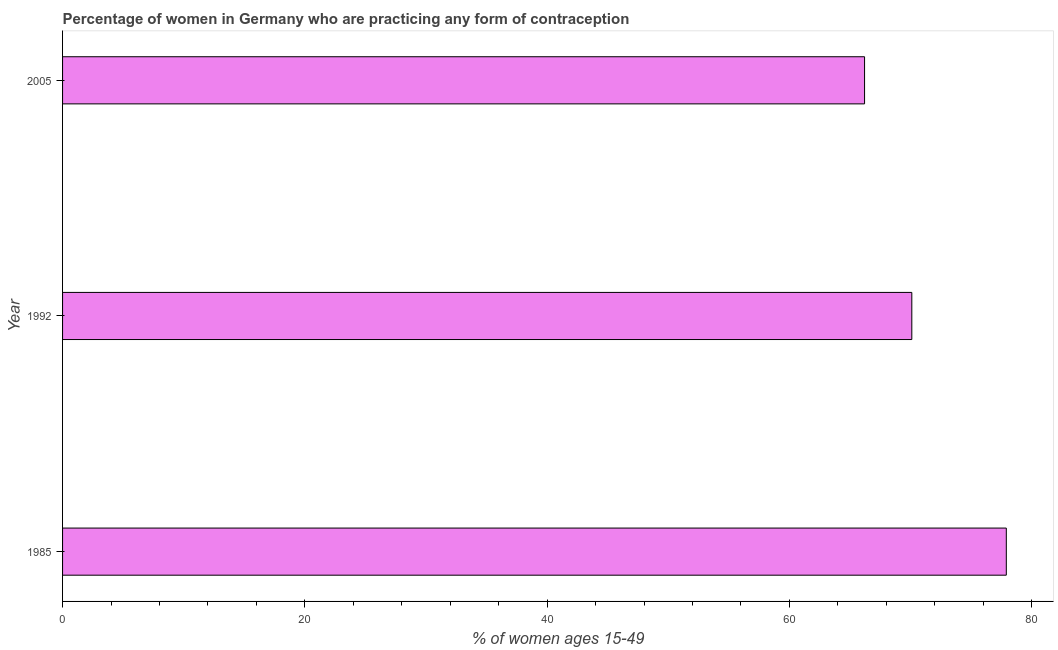Does the graph contain any zero values?
Your response must be concise. No. Does the graph contain grids?
Keep it short and to the point. No. What is the title of the graph?
Keep it short and to the point. Percentage of women in Germany who are practicing any form of contraception. What is the label or title of the X-axis?
Provide a succinct answer. % of women ages 15-49. What is the label or title of the Y-axis?
Keep it short and to the point. Year. What is the contraceptive prevalence in 1992?
Offer a very short reply. 70.1. Across all years, what is the maximum contraceptive prevalence?
Make the answer very short. 77.9. Across all years, what is the minimum contraceptive prevalence?
Give a very brief answer. 66.2. What is the sum of the contraceptive prevalence?
Ensure brevity in your answer.  214.2. What is the difference between the contraceptive prevalence in 1985 and 2005?
Your answer should be very brief. 11.7. What is the average contraceptive prevalence per year?
Your answer should be very brief. 71.4. What is the median contraceptive prevalence?
Your answer should be compact. 70.1. What is the ratio of the contraceptive prevalence in 1985 to that in 2005?
Offer a terse response. 1.18. Is the contraceptive prevalence in 1985 less than that in 1992?
Your response must be concise. No. Is the difference between the contraceptive prevalence in 1985 and 2005 greater than the difference between any two years?
Offer a terse response. Yes. How many bars are there?
Your response must be concise. 3. Are the values on the major ticks of X-axis written in scientific E-notation?
Provide a short and direct response. No. What is the % of women ages 15-49 in 1985?
Your answer should be compact. 77.9. What is the % of women ages 15-49 of 1992?
Offer a very short reply. 70.1. What is the % of women ages 15-49 in 2005?
Ensure brevity in your answer.  66.2. What is the difference between the % of women ages 15-49 in 1985 and 1992?
Give a very brief answer. 7.8. What is the difference between the % of women ages 15-49 in 1985 and 2005?
Your response must be concise. 11.7. What is the difference between the % of women ages 15-49 in 1992 and 2005?
Ensure brevity in your answer.  3.9. What is the ratio of the % of women ages 15-49 in 1985 to that in 1992?
Ensure brevity in your answer.  1.11. What is the ratio of the % of women ages 15-49 in 1985 to that in 2005?
Give a very brief answer. 1.18. What is the ratio of the % of women ages 15-49 in 1992 to that in 2005?
Make the answer very short. 1.06. 